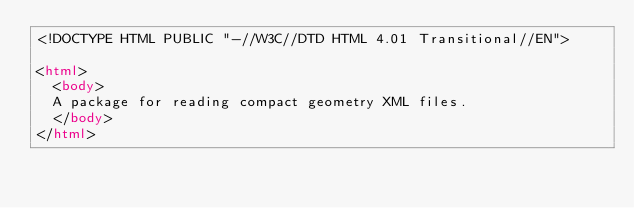<code> <loc_0><loc_0><loc_500><loc_500><_HTML_><!DOCTYPE HTML PUBLIC "-//W3C//DTD HTML 4.01 Transitional//EN">

<html>
  <body>
  A package for reading compact geometry XML files.
  </body>
</html>
</code> 